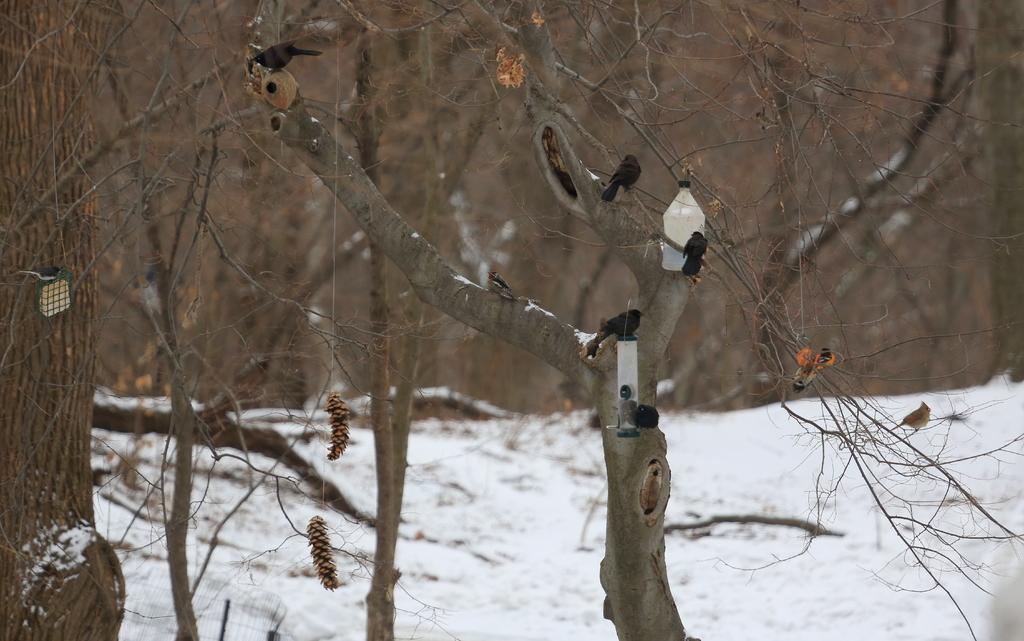Can you describe this image briefly? In this image I can see few birds sitting on the tree. The birds are in black color, I can see dried trees and snow in white color 